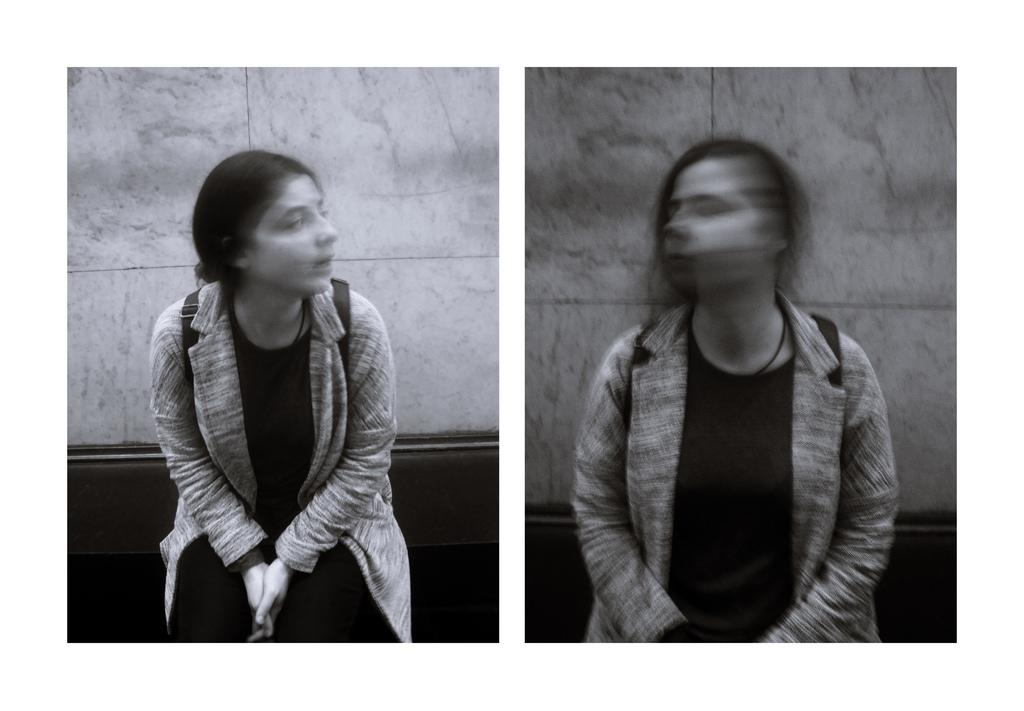What is the main subject of the image? The main subject of the image is photocopies of a person. Can you describe the condition of one of the photocopies? One of the photocopies is blurred. What else can be seen in the image besides the photocopies? There is a background visible in the image. What type of crime is being committed in the image? There is no indication of a crime being committed in the image; it features photocopies of a person and a background. Can you describe the porter's role in the image? There is no porter present in the image. 